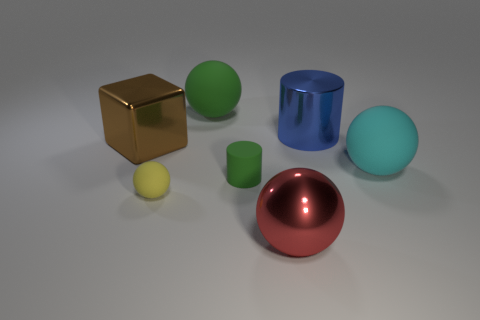There is a rubber object that is the same color as the tiny cylinder; what is its shape?
Ensure brevity in your answer.  Sphere. How many objects are either balls behind the brown object or cyan metal things?
Offer a very short reply. 1. What size is the yellow thing that is made of the same material as the tiny green thing?
Offer a very short reply. Small. There is a shiny cylinder; is its size the same as the metallic object that is to the left of the large red object?
Ensure brevity in your answer.  Yes. There is a big metal object that is to the right of the brown metallic cube and on the left side of the big metallic cylinder; what is its color?
Your answer should be compact. Red. How many objects are big rubber balls that are in front of the blue shiny cylinder or matte things that are behind the yellow object?
Ensure brevity in your answer.  3. There is a tiny object to the left of the green rubber object on the right side of the sphere behind the big brown thing; what is its color?
Your answer should be very brief. Yellow. Are there any green objects of the same shape as the big brown shiny thing?
Your response must be concise. No. How many large gray rubber blocks are there?
Make the answer very short. 0. There is a brown metallic thing; what shape is it?
Your response must be concise. Cube. 